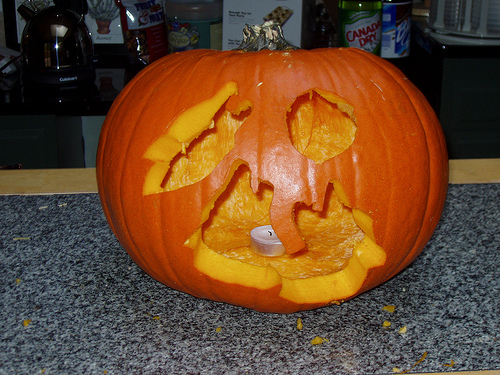<image>
Can you confirm if the bottle is next to the floor? No. The bottle is not positioned next to the floor. They are located in different areas of the scene. 